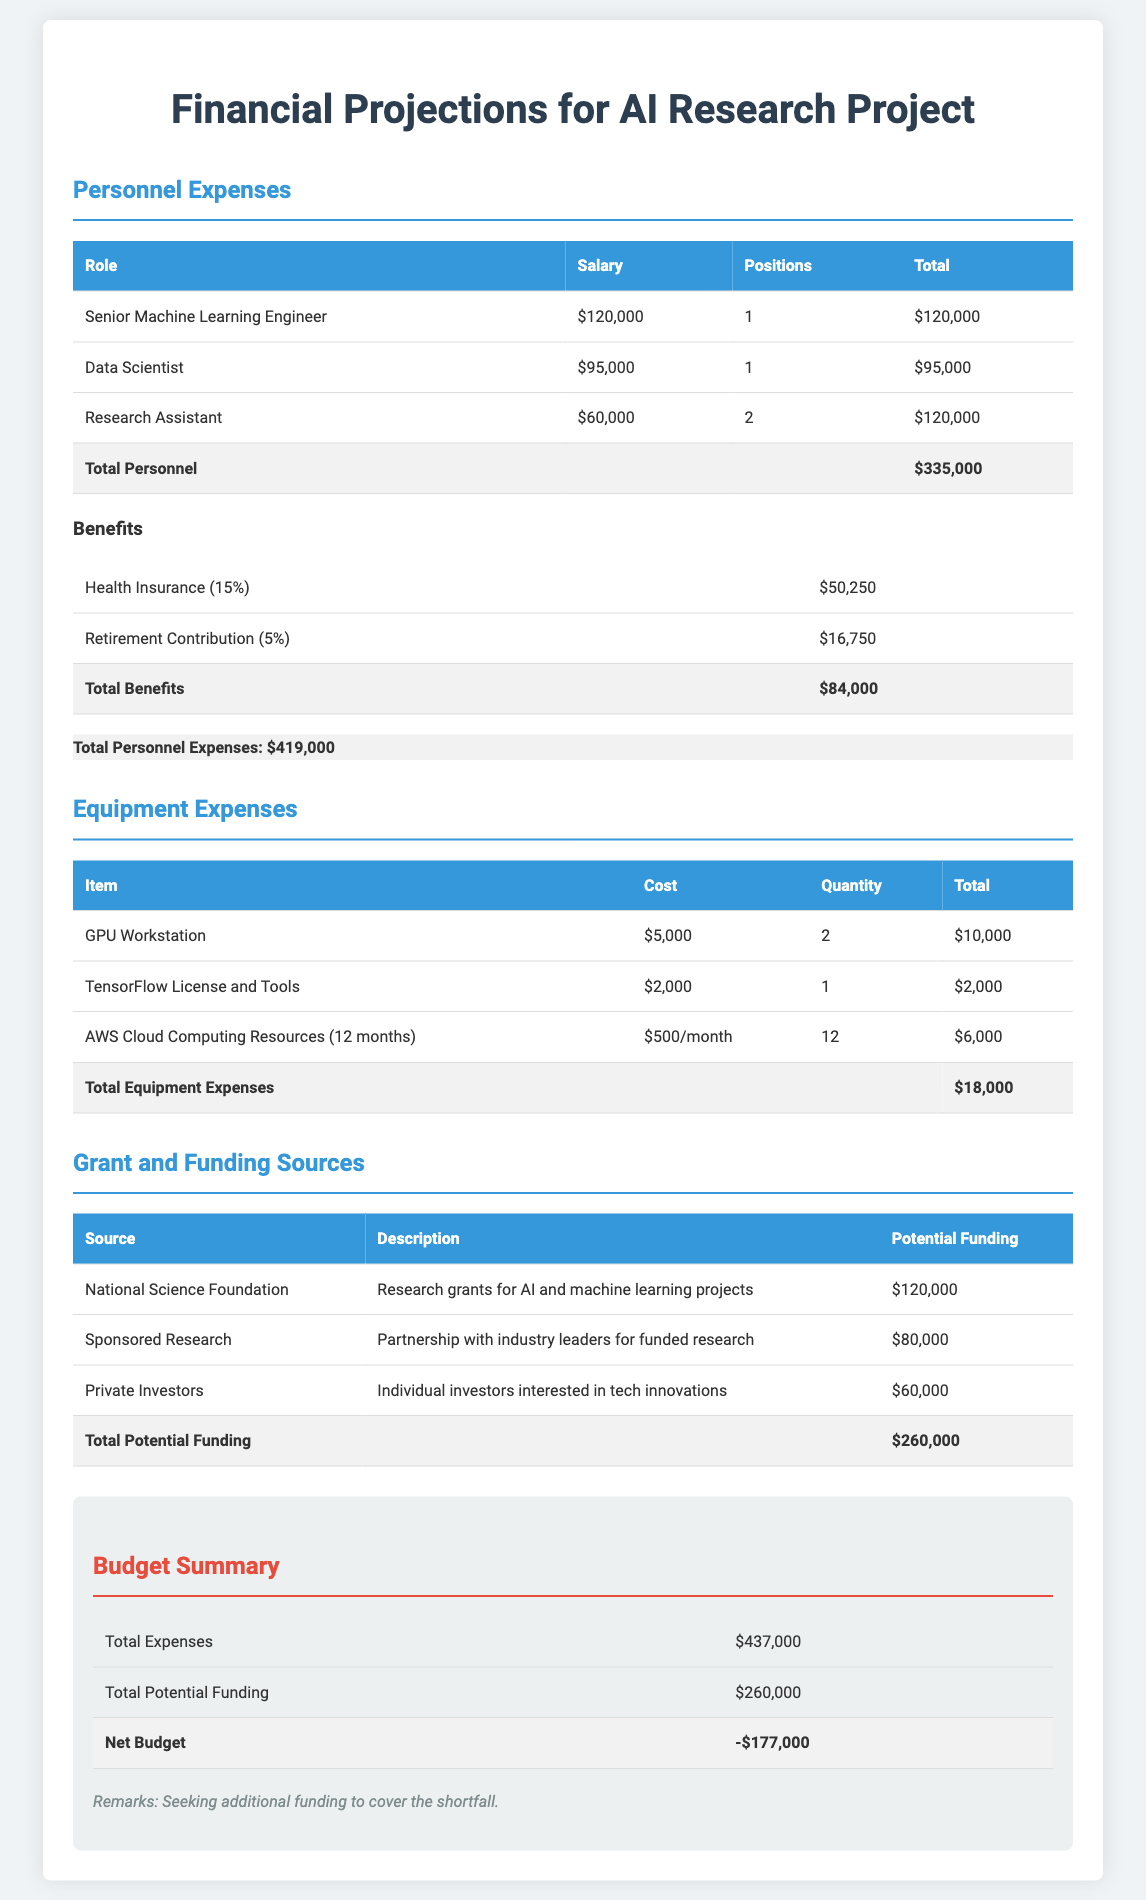What is the total personnel expense? The total personnel expense is the summation of all personnel costs listed in the document, which is $335,000 + $84,000 = $419,000.
Answer: $419,000 How many GPU workstations are budgeted for purchase? The number of GPU workstations is indicated in the equipment expenses table, which shows 2 units.
Answer: 2 What is the potential funding from the National Science Foundation? The potential funding from the National Science Foundation is listed in the grant and funding sources section, which is $120,000.
Answer: $120,000 What is the cost of a TensorFlow license and tools? The cost of the TensorFlow license and tools is detailed in the equipment expenses table, showing $2,000.
Answer: $2,000 What is the net budget amount? The net budget is calculated as total expenses minus total potential funding, which results in -$177,000.
Answer: -$177,000 What percentage of total personnel expenses is attributed to benefits? Total personnel expenses are $419,000 and total benefits are $84,000; thus, the percentage is calculated as ($84,000 / $419,000) * 100, resulting in approximately 20%.
Answer: 20% Which role has the highest salary in personnel expenses? The role with the highest salary is identified in the personnel expenses table, which is the Senior Machine Learning Engineer, earning $120,000.
Answer: Senior Machine Learning Engineer What are the total expected benefits from health insurance? The document specifies that health insurance benefits are 15% of total salaries, amounting to $50,250.
Answer: $50,250 Which funding source is expecting $80,000? The source expecting $80,000 is detailed in the grant and funding sources table, which is Sponsored Research.
Answer: Sponsored Research 